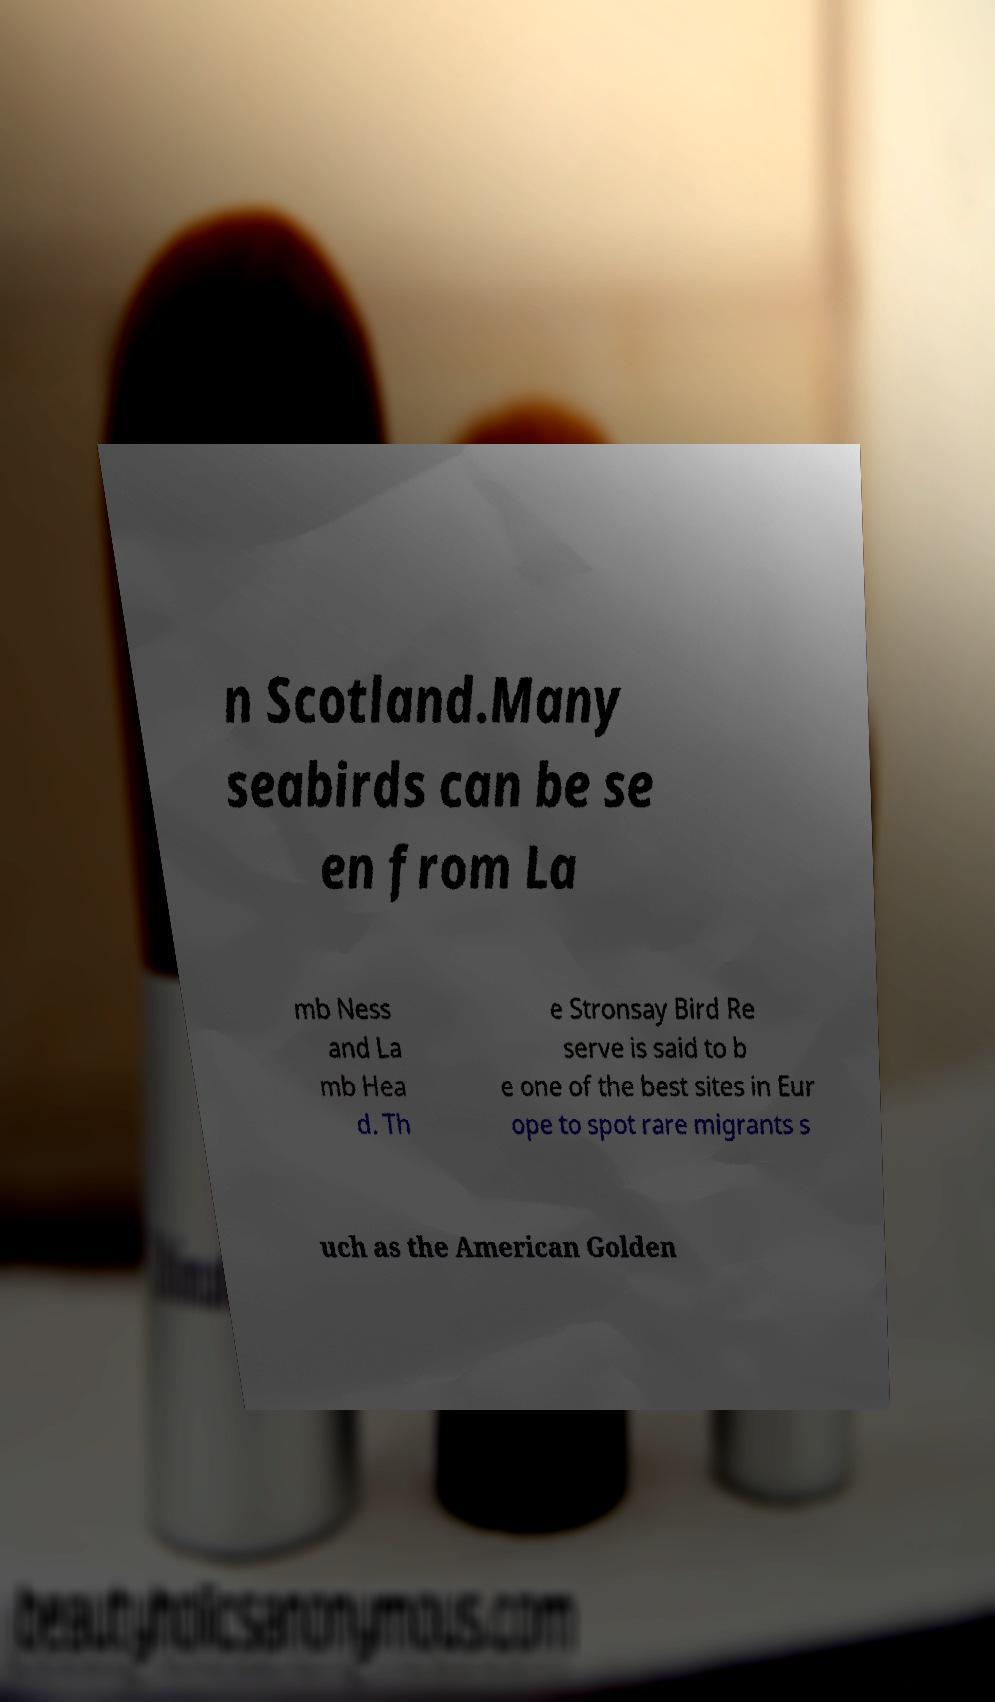Please identify and transcribe the text found in this image. n Scotland.Many seabirds can be se en from La mb Ness and La mb Hea d. Th e Stronsay Bird Re serve is said to b e one of the best sites in Eur ope to spot rare migrants s uch as the American Golden 